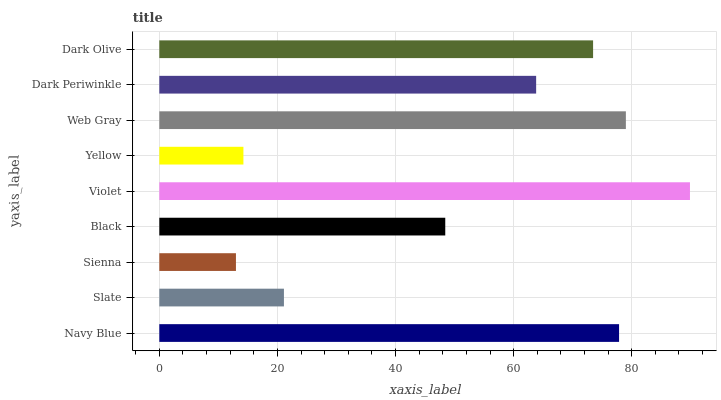Is Sienna the minimum?
Answer yes or no. Yes. Is Violet the maximum?
Answer yes or no. Yes. Is Slate the minimum?
Answer yes or no. No. Is Slate the maximum?
Answer yes or no. No. Is Navy Blue greater than Slate?
Answer yes or no. Yes. Is Slate less than Navy Blue?
Answer yes or no. Yes. Is Slate greater than Navy Blue?
Answer yes or no. No. Is Navy Blue less than Slate?
Answer yes or no. No. Is Dark Periwinkle the high median?
Answer yes or no. Yes. Is Dark Periwinkle the low median?
Answer yes or no. Yes. Is Dark Olive the high median?
Answer yes or no. No. Is Dark Olive the low median?
Answer yes or no. No. 